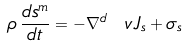Convert formula to latex. <formula><loc_0><loc_0><loc_500><loc_500>\rho \, { \frac { d s ^ { m } } { d t } } = - \nabla ^ { d } \ v J _ { s } + \sigma _ { s }</formula> 